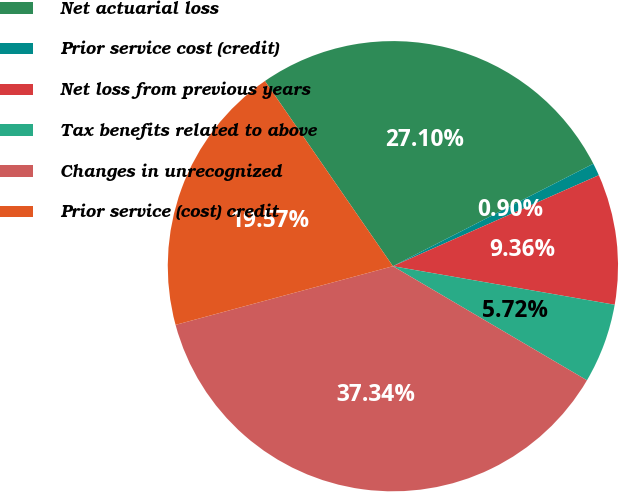Convert chart to OTSL. <chart><loc_0><loc_0><loc_500><loc_500><pie_chart><fcel>Net actuarial loss<fcel>Prior service cost (credit)<fcel>Net loss from previous years<fcel>Tax benefits related to above<fcel>Changes in unrecognized<fcel>Prior service (cost) credit<nl><fcel>27.1%<fcel>0.9%<fcel>9.36%<fcel>5.72%<fcel>37.34%<fcel>19.57%<nl></chart> 